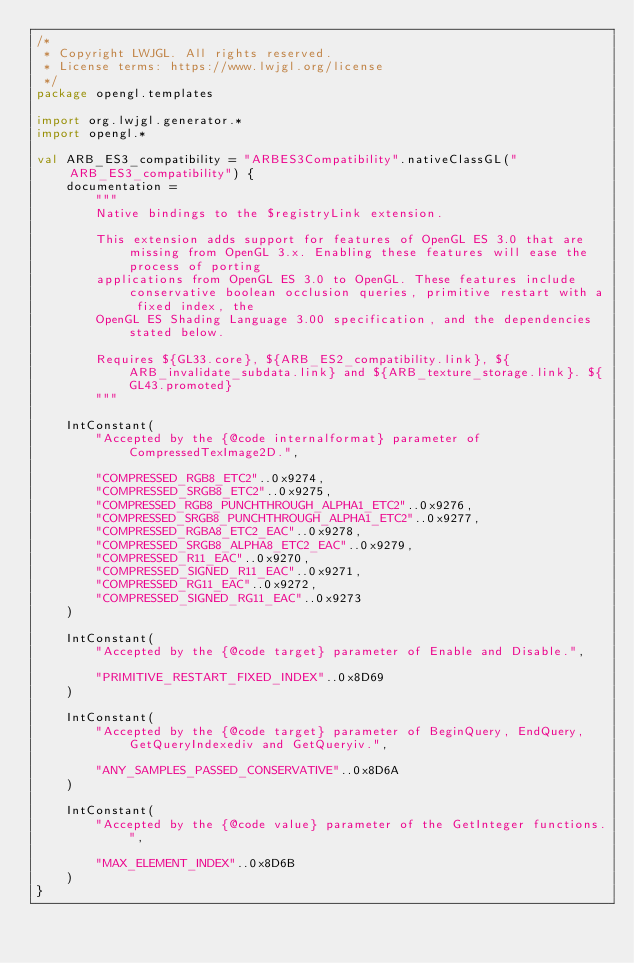<code> <loc_0><loc_0><loc_500><loc_500><_Kotlin_>/*
 * Copyright LWJGL. All rights reserved.
 * License terms: https://www.lwjgl.org/license
 */
package opengl.templates

import org.lwjgl.generator.*
import opengl.*

val ARB_ES3_compatibility = "ARBES3Compatibility".nativeClassGL("ARB_ES3_compatibility") {
    documentation =
        """
        Native bindings to the $registryLink extension.

        This extension adds support for features of OpenGL ES 3.0 that are missing from OpenGL 3.x. Enabling these features will ease the process of porting
        applications from OpenGL ES 3.0 to OpenGL. These features include conservative boolean occlusion queries, primitive restart with a fixed index, the
        OpenGL ES Shading Language 3.00 specification, and the dependencies stated below.

        Requires ${GL33.core}, ${ARB_ES2_compatibility.link}, ${ARB_invalidate_subdata.link} and ${ARB_texture_storage.link}. ${GL43.promoted}
        """

    IntConstant(
        "Accepted by the {@code internalformat} parameter of CompressedTexImage2D.",

        "COMPRESSED_RGB8_ETC2"..0x9274,
        "COMPRESSED_SRGB8_ETC2"..0x9275,
        "COMPRESSED_RGB8_PUNCHTHROUGH_ALPHA1_ETC2"..0x9276,
        "COMPRESSED_SRGB8_PUNCHTHROUGH_ALPHA1_ETC2"..0x9277,
        "COMPRESSED_RGBA8_ETC2_EAC"..0x9278,
        "COMPRESSED_SRGB8_ALPHA8_ETC2_EAC"..0x9279,
        "COMPRESSED_R11_EAC"..0x9270,
        "COMPRESSED_SIGNED_R11_EAC"..0x9271,
        "COMPRESSED_RG11_EAC"..0x9272,
        "COMPRESSED_SIGNED_RG11_EAC"..0x9273
    )

    IntConstant(
        "Accepted by the {@code target} parameter of Enable and Disable.",

        "PRIMITIVE_RESTART_FIXED_INDEX"..0x8D69
    )

    IntConstant(
        "Accepted by the {@code target} parameter of BeginQuery, EndQuery, GetQueryIndexediv and GetQueryiv.",

        "ANY_SAMPLES_PASSED_CONSERVATIVE"..0x8D6A
    )

    IntConstant(
        "Accepted by the {@code value} parameter of the GetInteger functions.",

        "MAX_ELEMENT_INDEX"..0x8D6B
    )
}</code> 